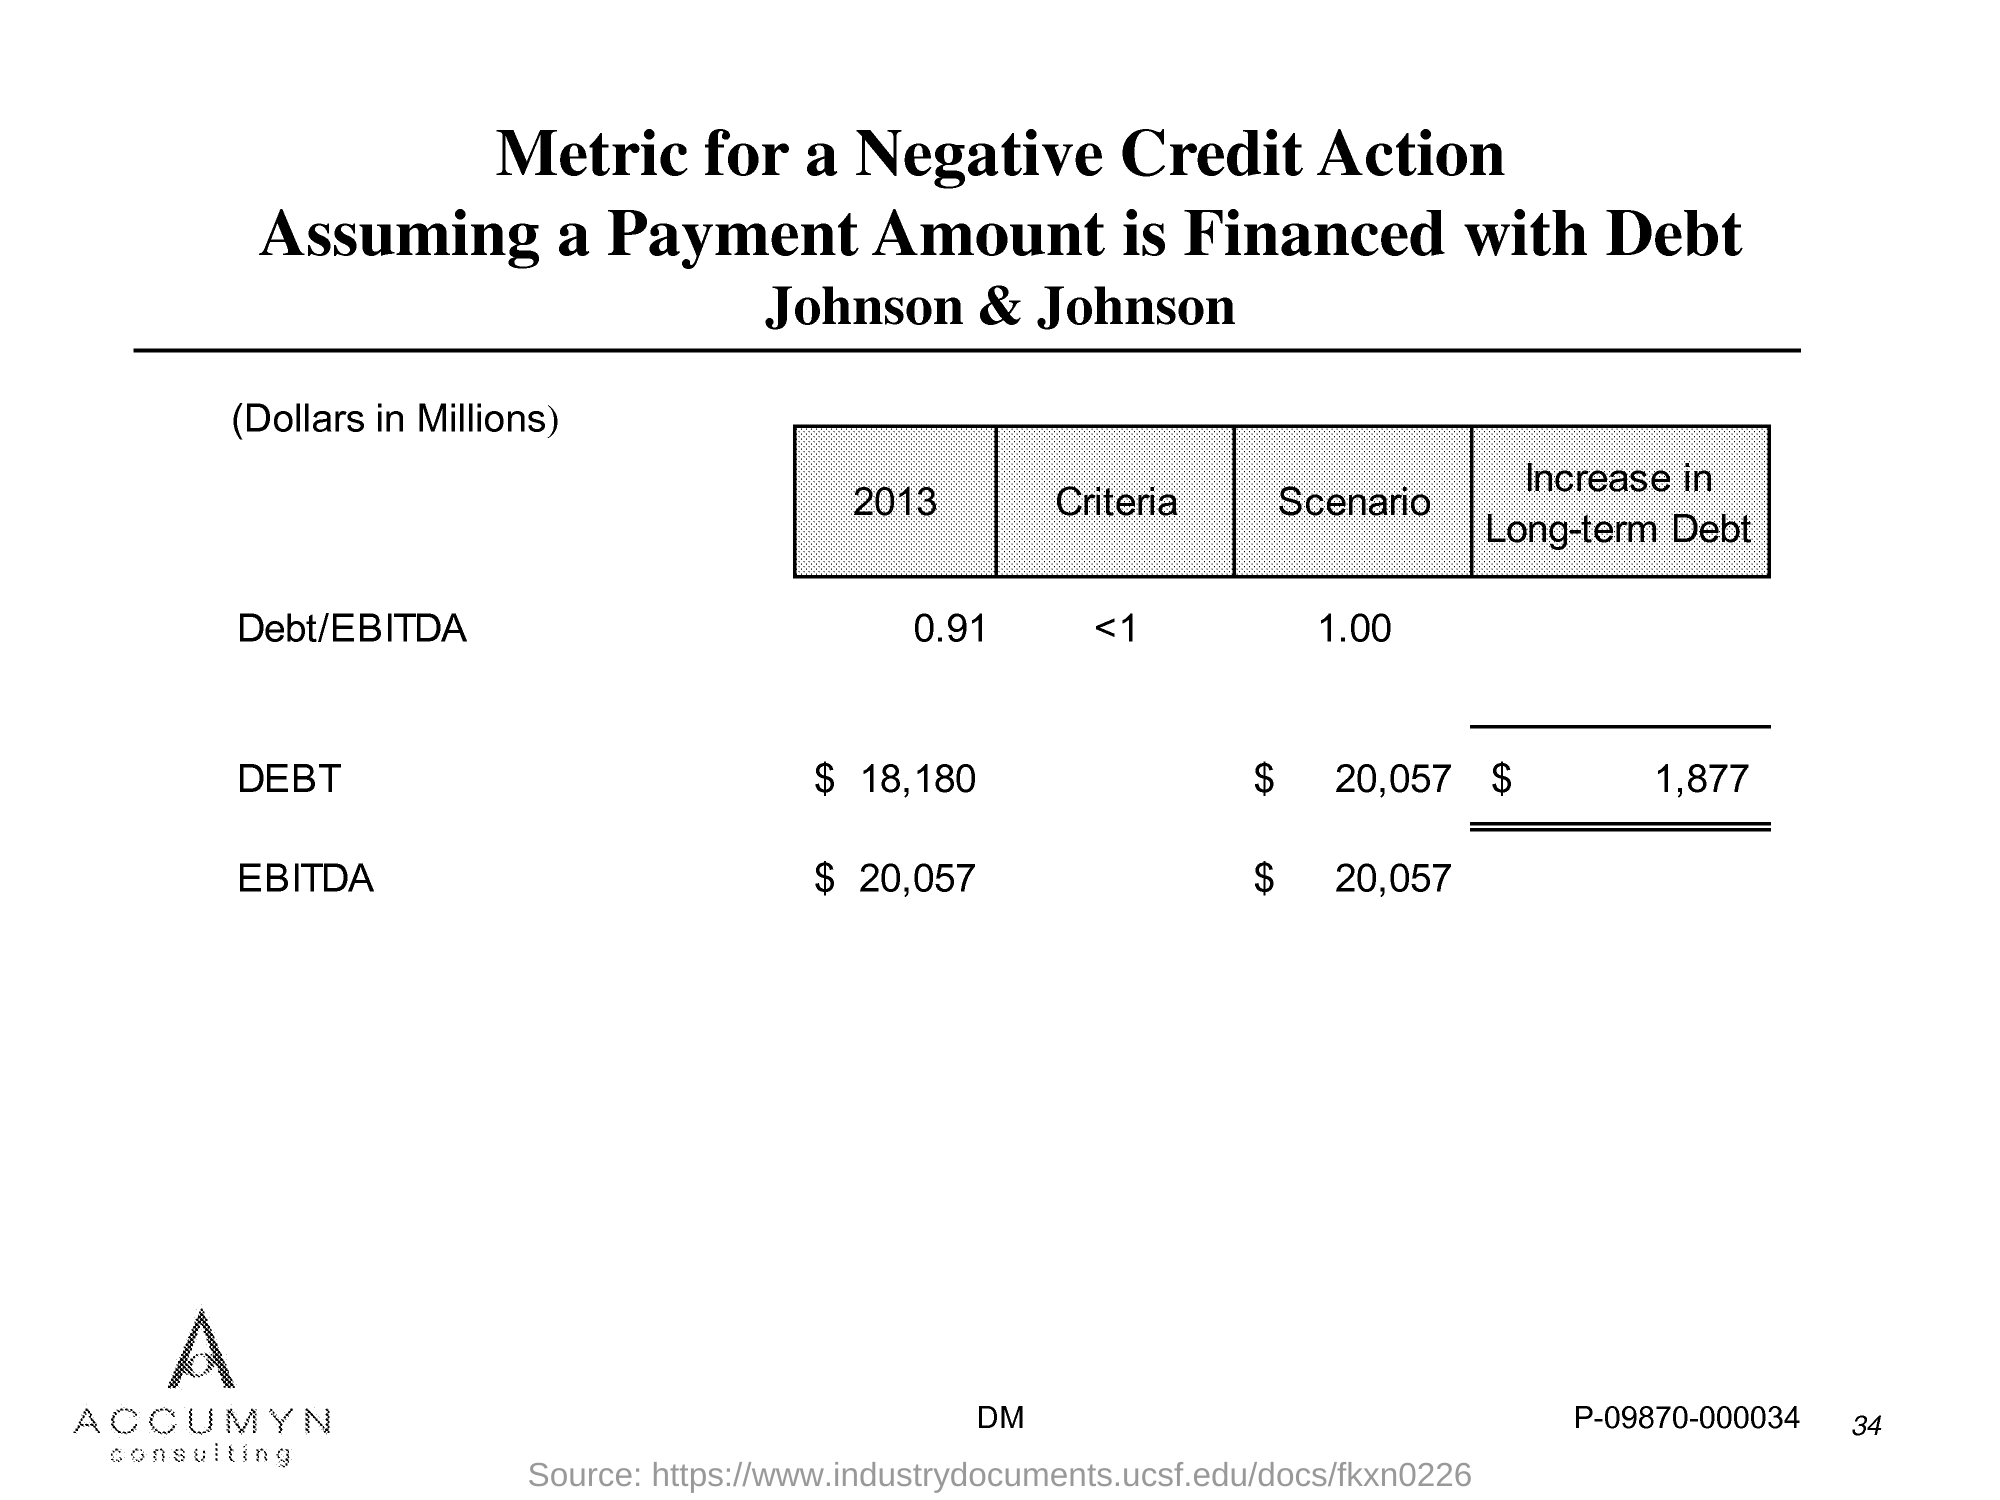What is the Page Number?
Give a very brief answer. 34. 